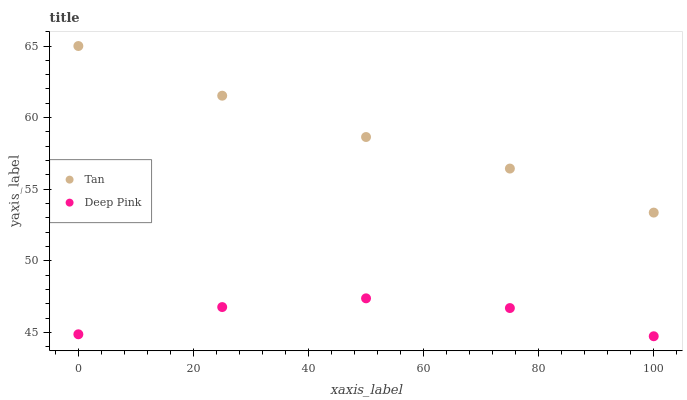Does Deep Pink have the minimum area under the curve?
Answer yes or no. Yes. Does Tan have the maximum area under the curve?
Answer yes or no. Yes. Does Deep Pink have the maximum area under the curve?
Answer yes or no. No. Is Tan the smoothest?
Answer yes or no. Yes. Is Deep Pink the roughest?
Answer yes or no. Yes. Is Deep Pink the smoothest?
Answer yes or no. No. Does Deep Pink have the lowest value?
Answer yes or no. Yes. Does Tan have the highest value?
Answer yes or no. Yes. Does Deep Pink have the highest value?
Answer yes or no. No. Is Deep Pink less than Tan?
Answer yes or no. Yes. Is Tan greater than Deep Pink?
Answer yes or no. Yes. Does Deep Pink intersect Tan?
Answer yes or no. No. 